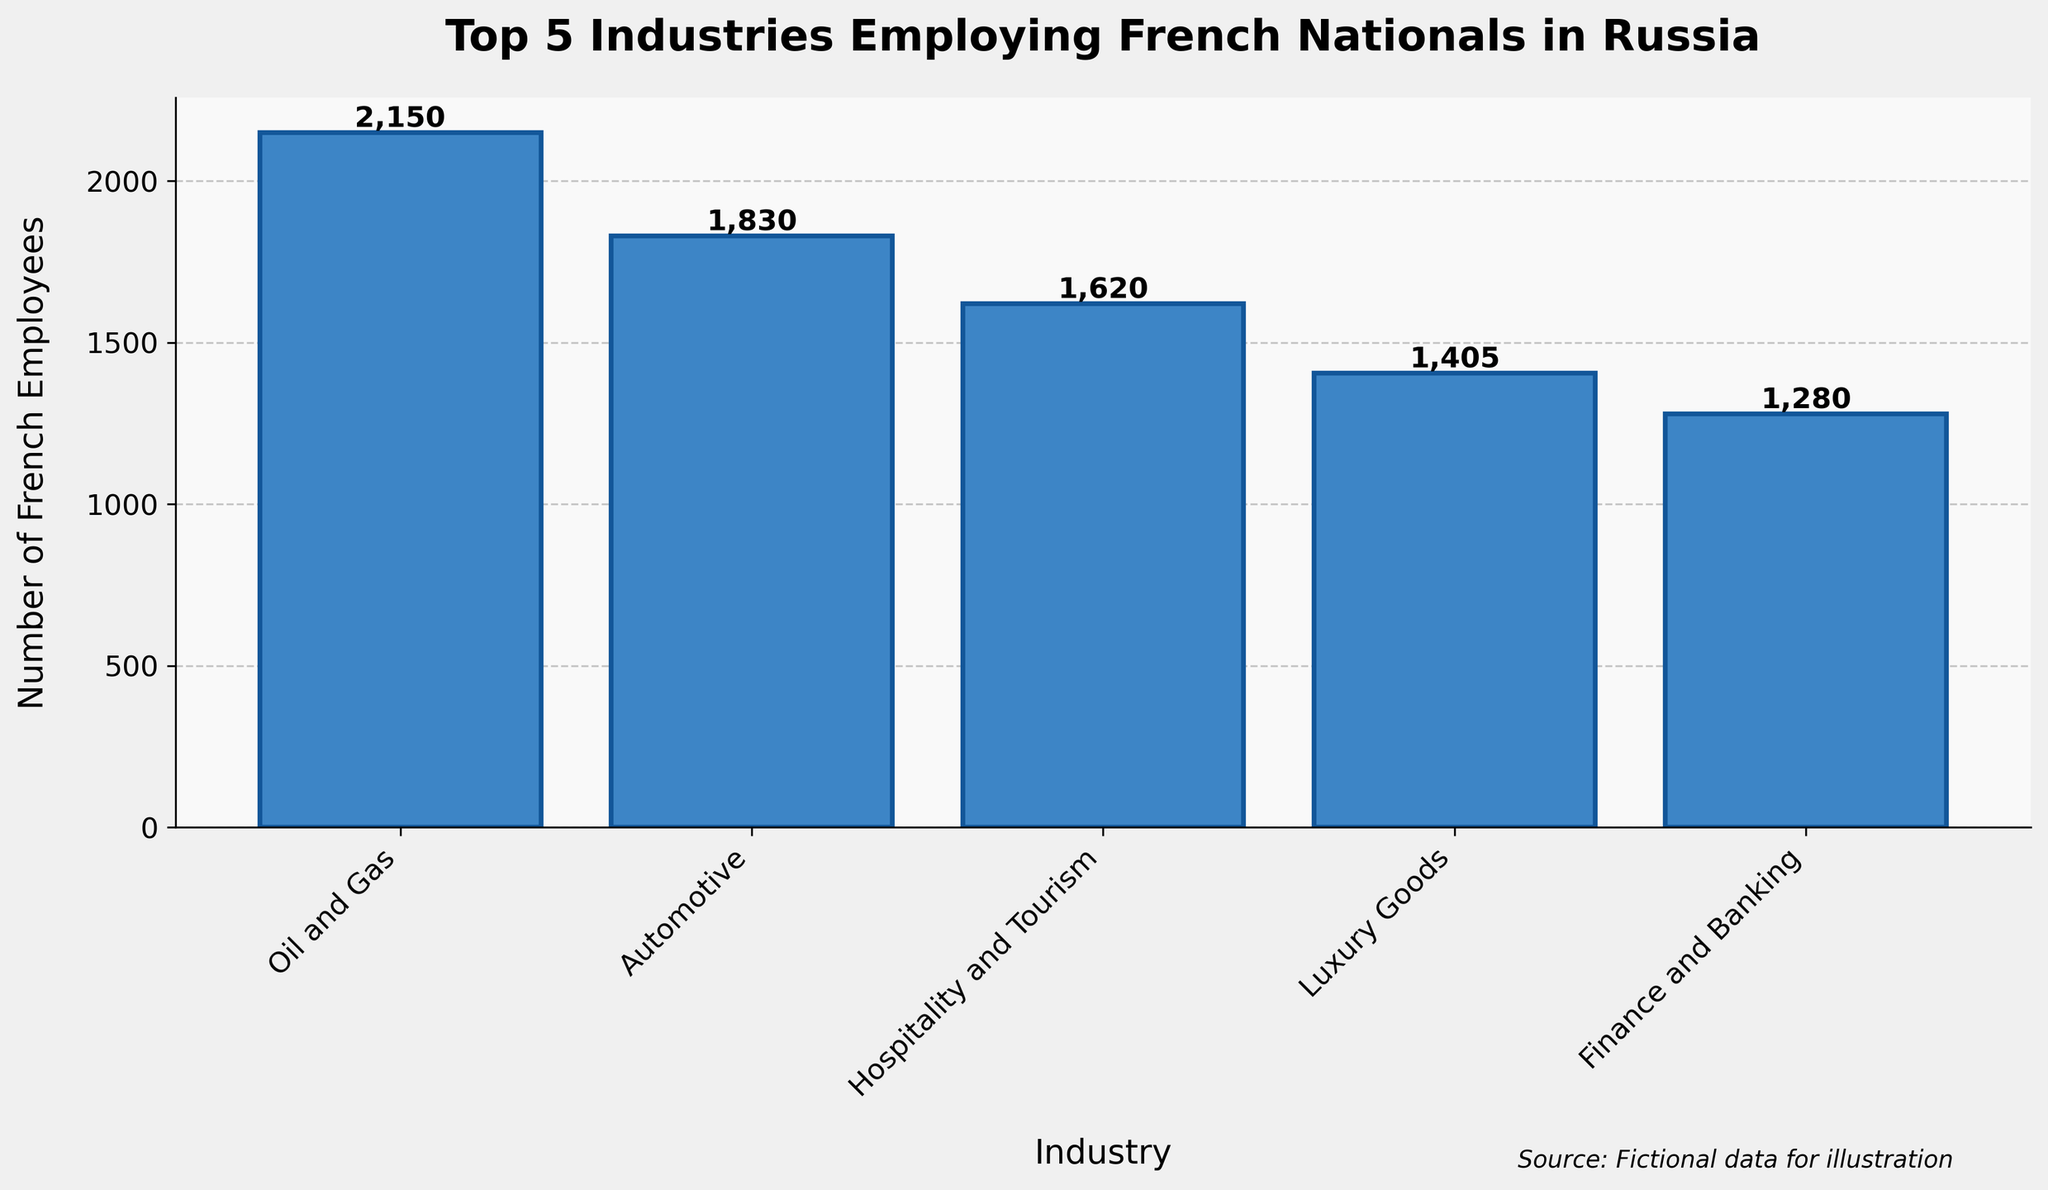what's the total number of French employees in all top 5 industries? Sum the number of French employees in each industry: 2150 (Oil and Gas) + 1830 (Automotive) + 1620 (Hospitality and Tourism) + 1405 (Luxury Goods) + 1280 (Finance and Banking) = 8285
Answer: 8285 Which industry employs the most French nationals in Russia? Look at the height of the bars; the highest bar corresponds to the Oil and Gas industry with 2150 employees
Answer: Oil and Gas Which industry employs fewer French nationals: Finance and Banking or Luxury Goods? Compare the heights of the bars for Finance and Banking (1280) and Luxury Goods (1405); the shorter bar corresponds to Finance and Banking which has 1280 employees
Answer: Finance and Banking How many more French employees are in the Automotive sector compared to the Finance and Banking sector? Subtract the number of employees in Finance and Banking (1280) from the number in the Automotive sector (1830): 1830 - 1280 = 550
Answer: 550 What is the average number of French employees in the top 5 industries? Sum the number of French employees: 2150 + 1830 + 1620 + 1405 + 1280 = 8285, then divide by 5: 8285 / 5 = 1657
Answer: 1657 Rank the top 5 industries in descending order according to the number of French employees. Compare the numbers for each industry and order them from the highest to the lowest: Oil and Gas (2150), Automotive (1830), Hospitality and Tourism (1620), Luxury Goods (1405), Finance and Banking (1280)
Answer: Oil and Gas, Automotive, Hospitality and Tourism, Luxury Goods, Finance and Banking Which industry employs the second-highest number of French employees in Russia? The second-highest bar corresponds to the Automotive industry with 1830 employees
Answer: Automotive Are there more French employees in the Hospitality and Tourism sector than in the combined Finance and Banking and Luxury Goods sectors? Sum the number of employees in Finance and Banking (1280) and Luxury Goods (1405): 1280 + 1405 = 2685, then compare it with the number in Hospitality and Tourism (1620) — 2685 is greater than 1620
Answer: No Which industry employs the least number of French nationals in Russia? Look at the shortest bar; it corresponds to Finance and Banking with 1280 employees
Answer: Finance and Banking What is the difference in the number of employees between the industry with the most French employees and the industry with the least French employees? Subtract the number of employees in Finance and Banking (1280) from the number in Oil and Gas (2150): 2150 - 1280 = 870
Answer: 870 